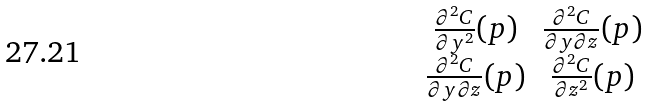<formula> <loc_0><loc_0><loc_500><loc_500>\begin{matrix} \frac { \partial ^ { 2 } C } { \partial y ^ { 2 } } ( p ) & \frac { \partial ^ { 2 } C } { \partial y \partial z } ( p ) \\ \frac { \partial ^ { 2 } C } { \partial y \partial z } ( p ) & \frac { \partial ^ { 2 } C } { \partial z ^ { 2 } } ( p ) \end{matrix}</formula> 